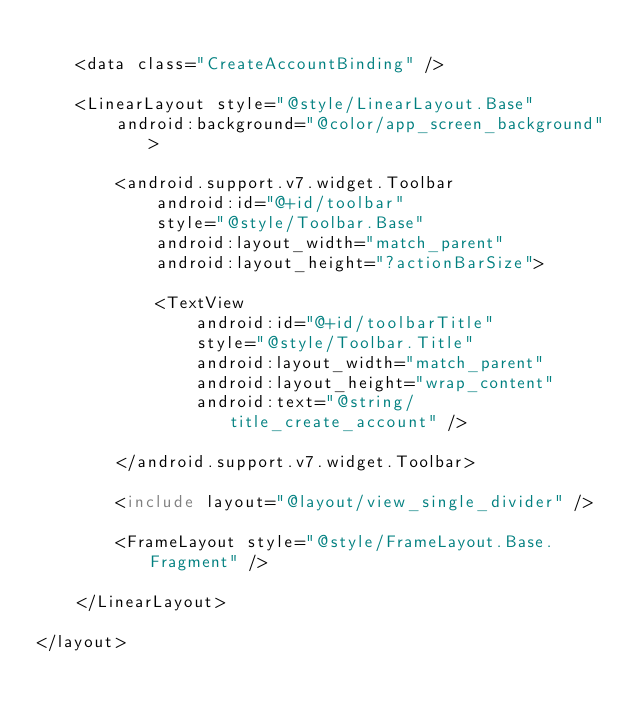<code> <loc_0><loc_0><loc_500><loc_500><_XML_>
    <data class="CreateAccountBinding" />

    <LinearLayout style="@style/LinearLayout.Base"
        android:background="@color/app_screen_background">

        <android.support.v7.widget.Toolbar
            android:id="@+id/toolbar"
            style="@style/Toolbar.Base"
            android:layout_width="match_parent"
            android:layout_height="?actionBarSize">

            <TextView
                android:id="@+id/toolbarTitle"
                style="@style/Toolbar.Title"
                android:layout_width="match_parent"
                android:layout_height="wrap_content"
                android:text="@string/title_create_account" />

        </android.support.v7.widget.Toolbar>

        <include layout="@layout/view_single_divider" />

        <FrameLayout style="@style/FrameLayout.Base.Fragment" />

    </LinearLayout>

</layout></code> 